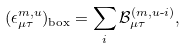<formula> <loc_0><loc_0><loc_500><loc_500>( \epsilon ^ { m , u } _ { \mu \tau } ) _ { \text {box} } = \sum _ { i } \mathcal { B } ^ { ( m , u \text {-} i ) } _ { \mu \tau } ,</formula> 